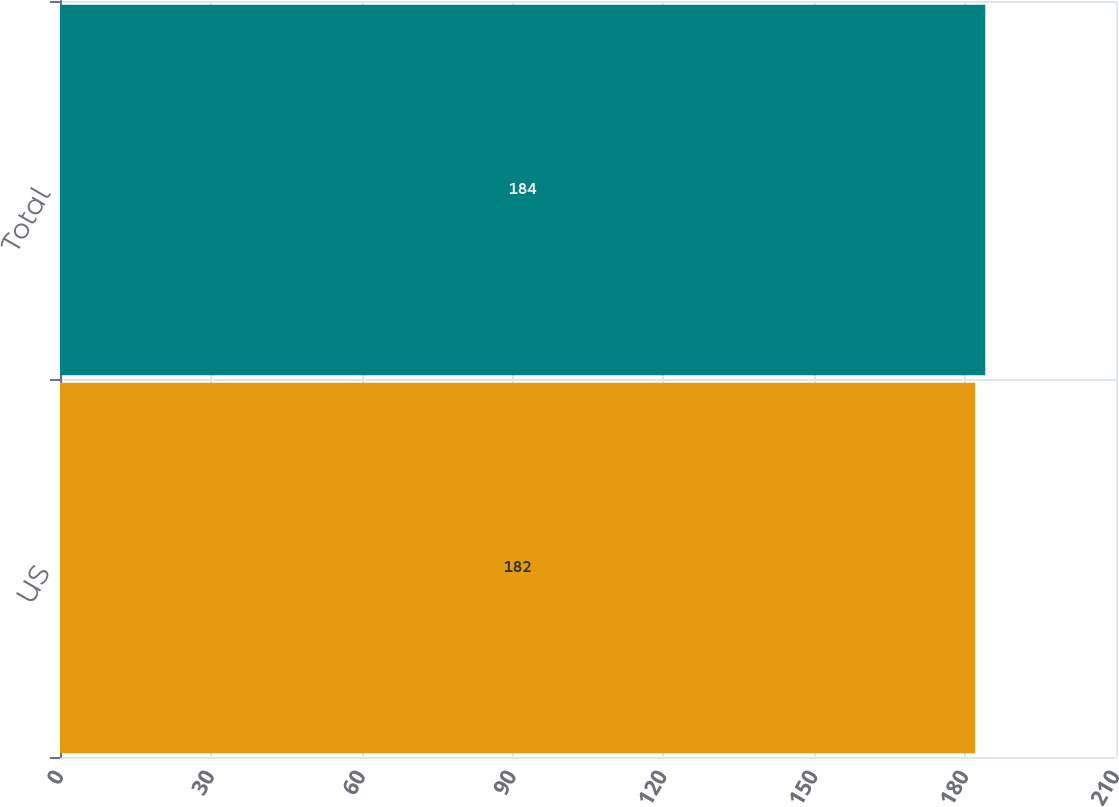Convert chart to OTSL. <chart><loc_0><loc_0><loc_500><loc_500><bar_chart><fcel>US<fcel>Total<nl><fcel>182<fcel>184<nl></chart> 